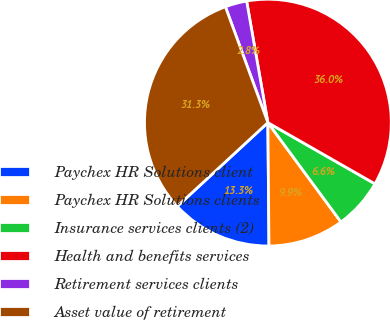Convert chart to OTSL. <chart><loc_0><loc_0><loc_500><loc_500><pie_chart><fcel>Paychex HR Solutions client<fcel>Paychex HR Solutions clients<fcel>Insurance services clients (2)<fcel>Health and benefits services<fcel>Retirement services clients<fcel>Asset value of retirement<nl><fcel>13.27%<fcel>9.95%<fcel>6.64%<fcel>36.02%<fcel>2.84%<fcel>31.28%<nl></chart> 